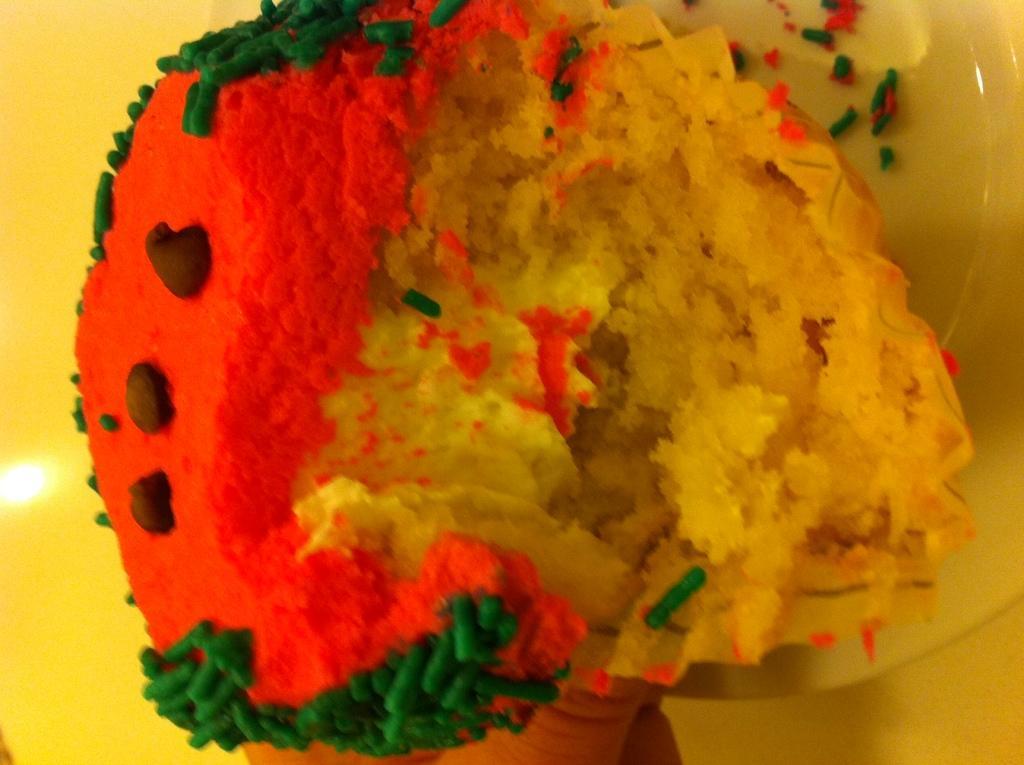Please provide a concise description of this image. In this picture we can see a colorful cupcake. 